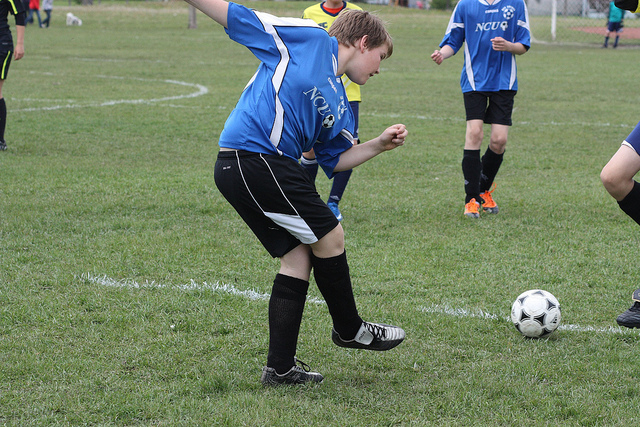Identify the text displayed in this image. NCU NCU 